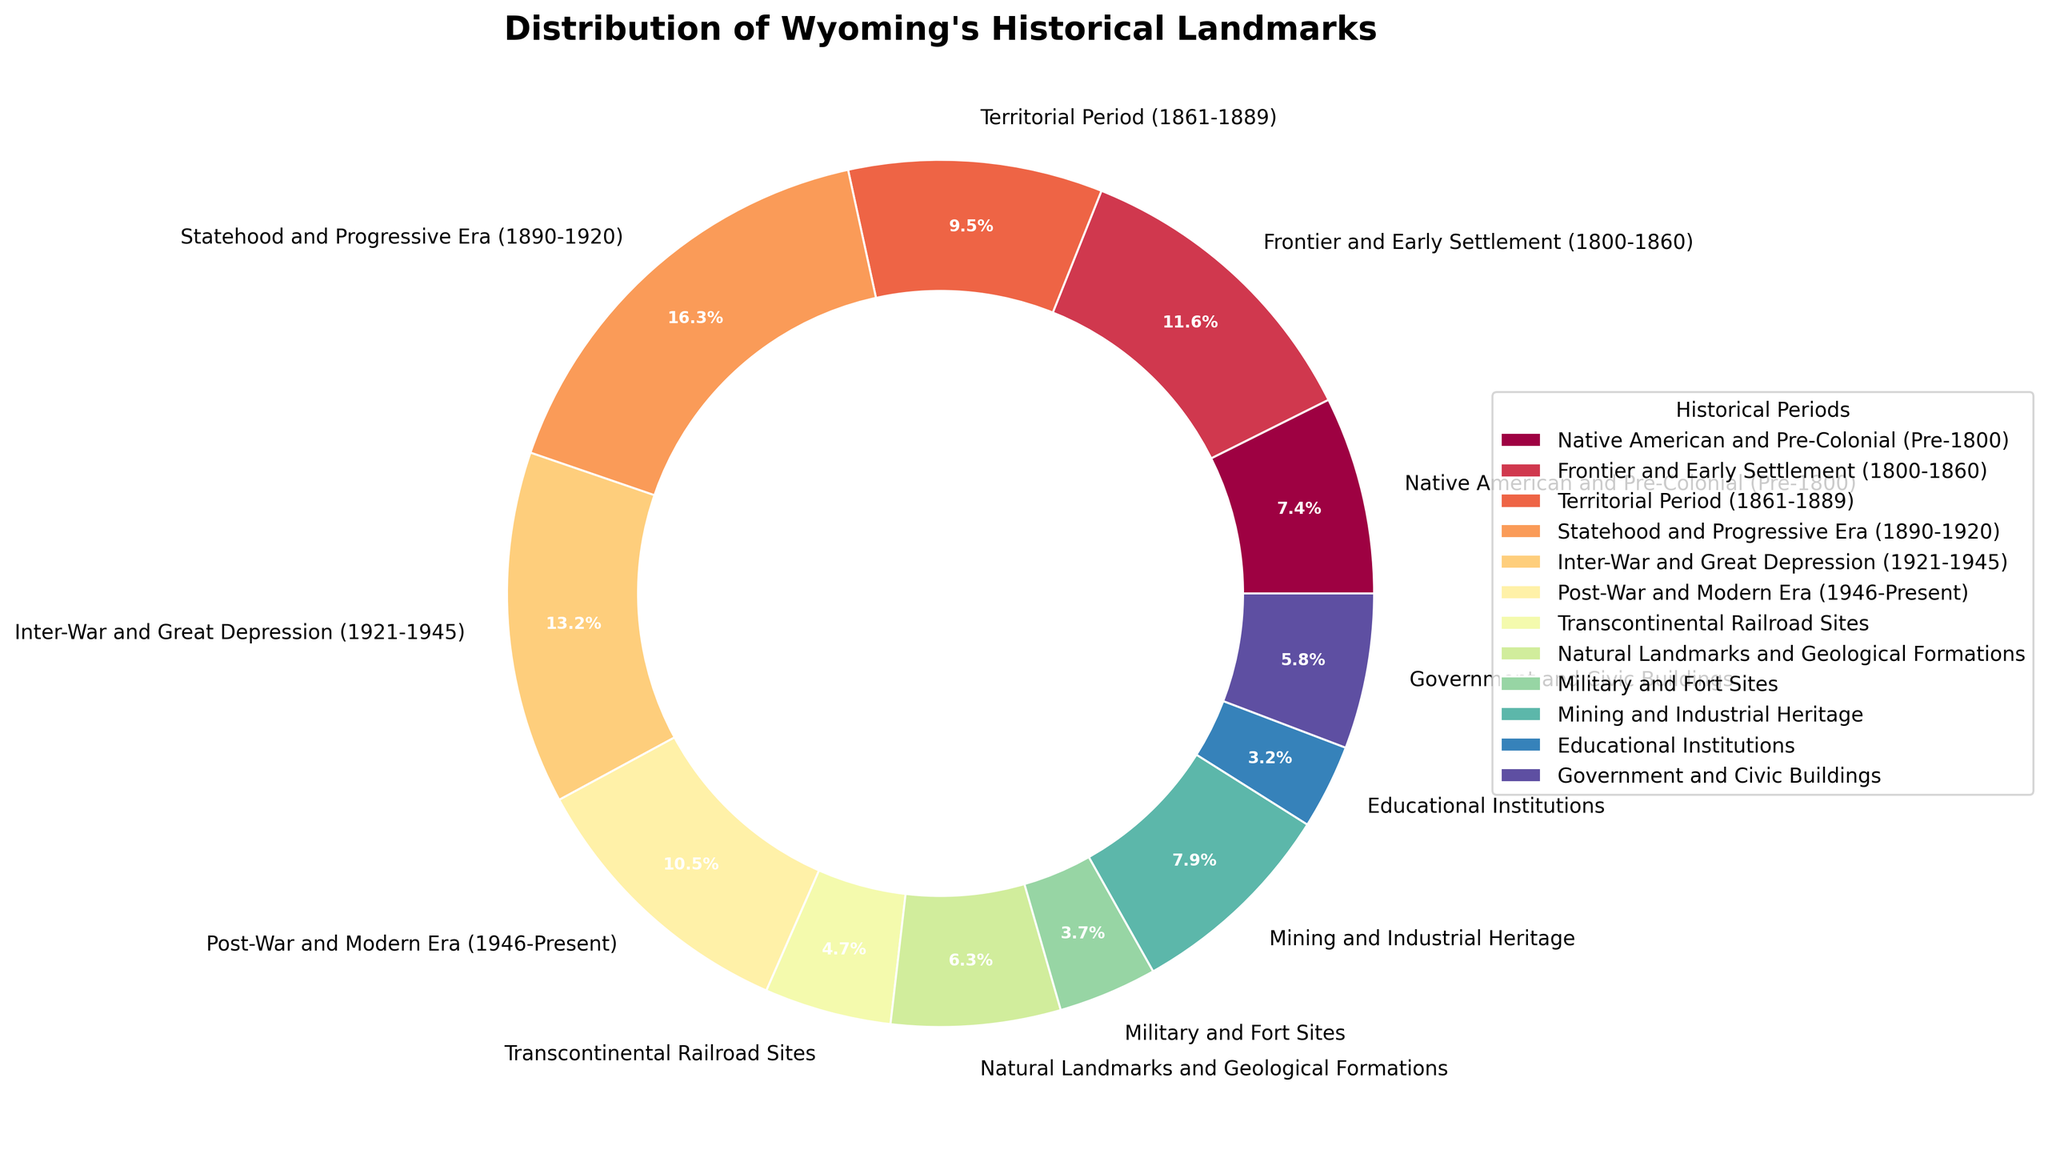Which period has the most historical landmarks? Look at which slice of the pie chart occupies the largest area and has the largest percentage. The "Statehood and Progressive Era (1890-1920)" takes up the largest portion at 31 landmarks.
Answer: Statehood and Progressive Era (1890-1920) Which two periods have the least number of historical landmarks combined? Identify the two smallest slices on the pie chart. "Educational Institutions" and "Military and Fort Sites" are the smallest, with 6 and 7 landmarks respectively. Adding these gives 13 landmarks.
Answer: Military and Fort Sites & Educational Institutions, 13 landmarks Are there more historical landmarks from the "Territorial Period (1861-1889)" or from the "Post-War and Modern Era (1946-Present)"? Compare the sizes of the slices for the two periods in the pie chart. The slice for "Territorial Period" is slightly larger with 18 landmarks compared to 20 for "Post-War and Modern Era."
Answer: Post-War and Modern Era How does the number of landmarks in the "Inter-War and Great Depression (1921-1945)" compare to the "Mining and Industrial Heritage"? Compare the sizes of the slices for the two periods. The "Inter-War and Great Depression" slice is larger with 25 landmarks, whereas the "Mining and Industrial Heritage" has 15 landmarks.
Answer: Inter-War and Great Depression What percentage of historical landmarks are designated as "Natural Landmarks and Geological Formations"? Look at the pie chart segment labeled "Natural Landmarks and Geological Formations" which shows 12 landmarks. The pie chart provides the percentage, which can be directly read off.
Answer: 11.3% If you sum the landmarks from the "Native American and Pre-Colonial (Pre-1800)" and "Frontier and Early Settlement (1800-1860)" periods, how many landmark sites are there in total? Add the number of landmarks from both periods. "Native American and Pre-Colonial" has 14 and "Frontier and Early Settlement" has 22, so the total is 14 + 22 = 36.
Answer: 36 Are the landmarks for "Transcontinental Railroad Sites" greater than those for "Educational Institutions"? Compare the number of landmarks for both categories. "Transcontinental Railroad Sites" has 9 landmarks, while "Educational Institutions" has 6.
Answer: Yes What is the difference in the number of landmarks between "Government and Civic Buildings" and "Mining and Industrial Heritage"? Subtract the number of landmarks in "Government and Civic Buildings" from "Mining and Industrial Heritage." "Mining and Industrial Heritage" has 15 landmarks, "Government and Civic Buildings" has 11, so 15 - 11 = 4.
Answer: 4 Which period's landmarks represent exactly 9% of the total landmarks? Look at the pie chart slice that is labeled as 9%. This slice corresponds to "Post-War and Modern Era (1946-Present)" with 20 landmarks.
Answer: Post-War and Modern Era (1946-Present) Are the landmarks from the "Statehood and Progressive Era (1890-1920)" more than the combined landmarks of "Territorial Period (1861-1889)" and "Native American and Pre-Colonial (Pre-1800)"? Add the number of landmarks from "Territorial Period" (18) and "Native American and Pre-Colonial" (14) to get 32, and compare with the 31 from "Statehood and Progressive Era."
Answer: No 